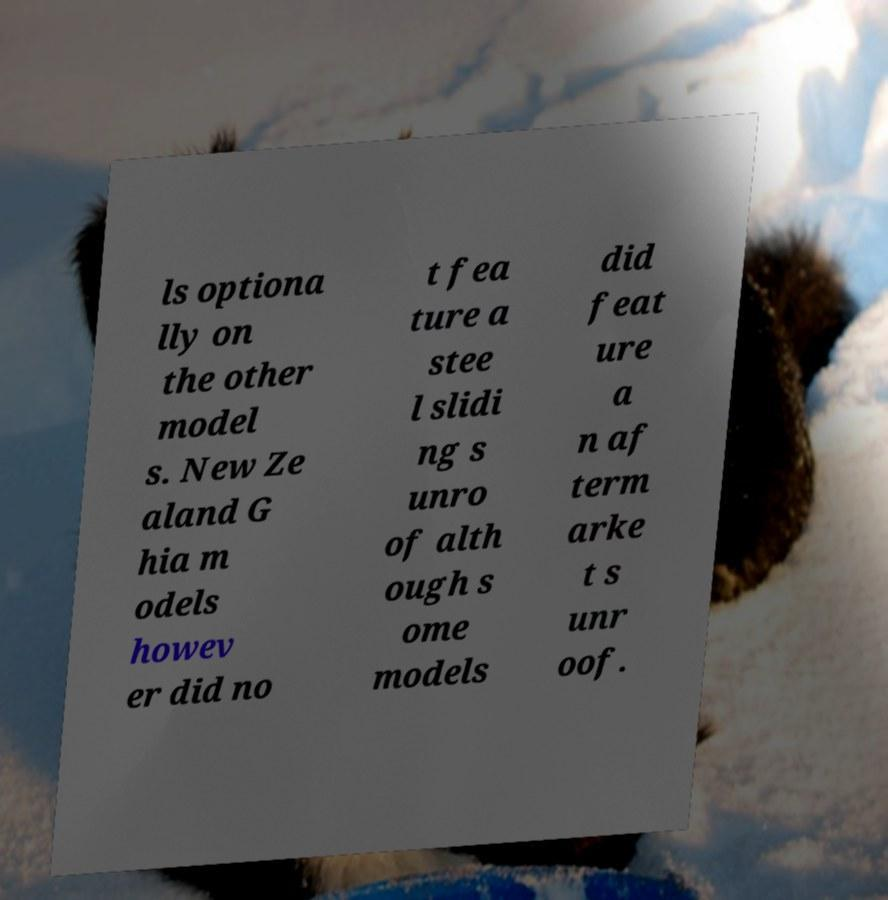Please identify and transcribe the text found in this image. ls optiona lly on the other model s. New Ze aland G hia m odels howev er did no t fea ture a stee l slidi ng s unro of alth ough s ome models did feat ure a n af term arke t s unr oof. 